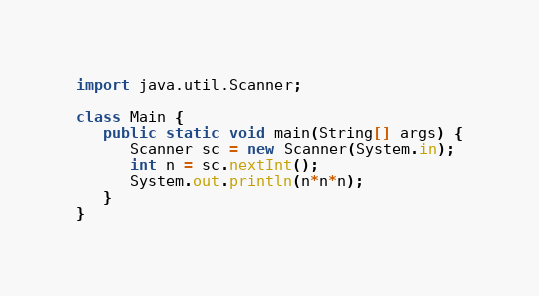<code> <loc_0><loc_0><loc_500><loc_500><_Java_>import java.util.Scanner;

class Main {
   public static void main(String[] args) {
      Scanner sc = new Scanner(System.in);
      int n = sc.nextInt();
      System.out.println(n*n*n);
   }
}

</code> 